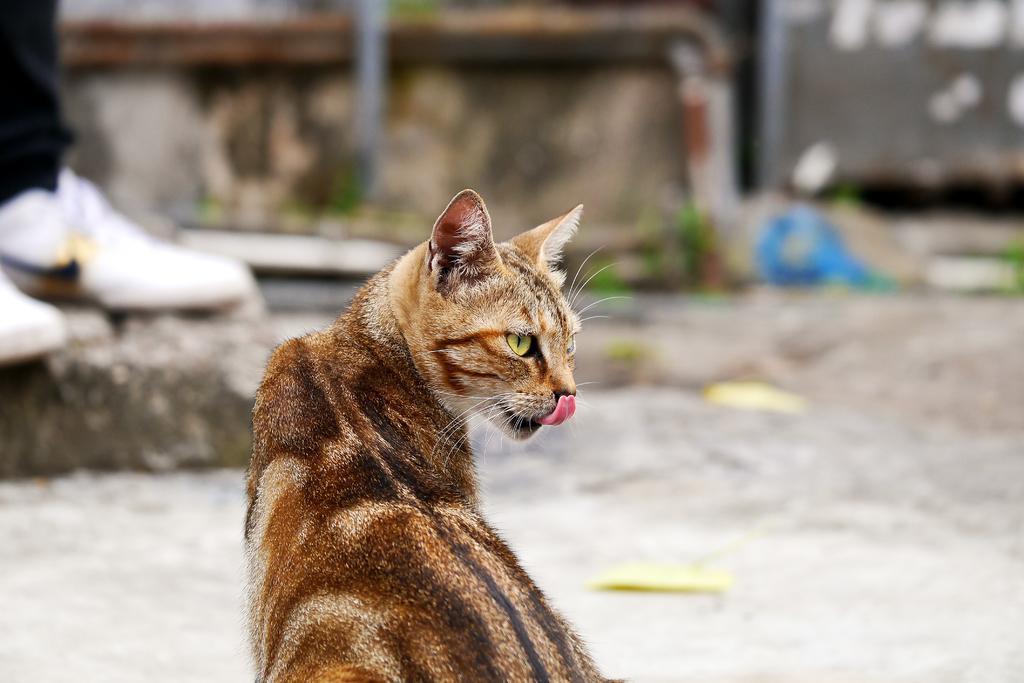Describe this image in one or two sentences. In this image I can see a car which is in black brown and white color. Back Side I can see rock and white color shoe is on it. Background is blurred. 